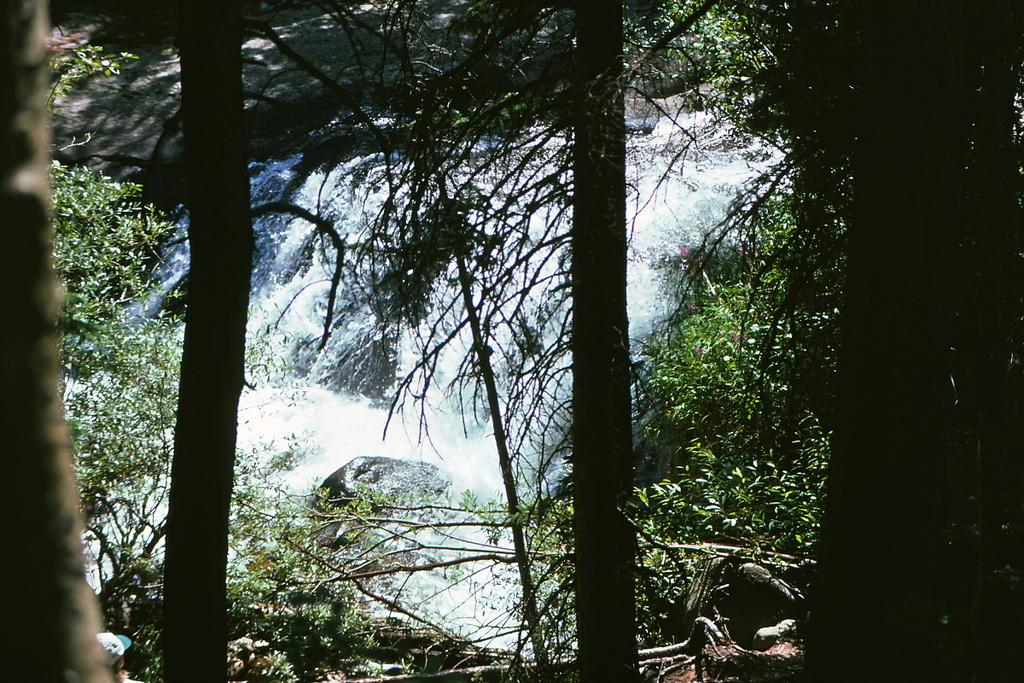What natural feature is the main subject of the image? There is a waterfall in the image. What can be seen at the base of the waterfall? Rocks are visible at the bottom of the waterfall. What type of vegetation is present in the image? There are many trees in the image. What type of maid can be seen cleaning the rocks at the bottom of the waterfall in the image? There is no maid present in the image; it features a waterfall with rocks at the bottom and many trees. 